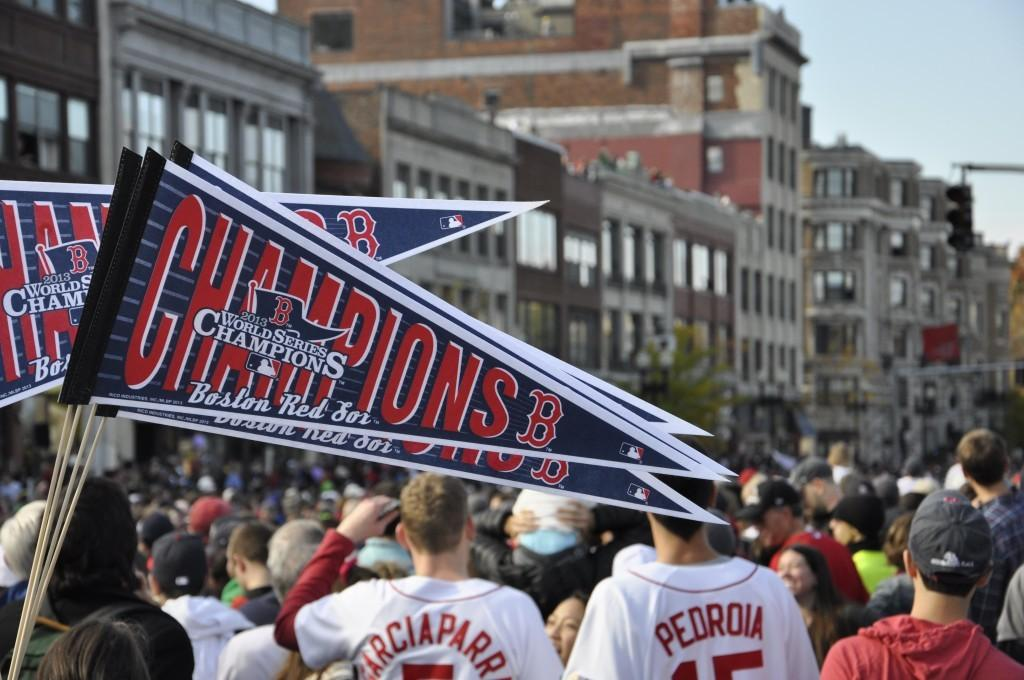<image>
Relay a brief, clear account of the picture shown. boston red sox 2013 world series champions group of fans 